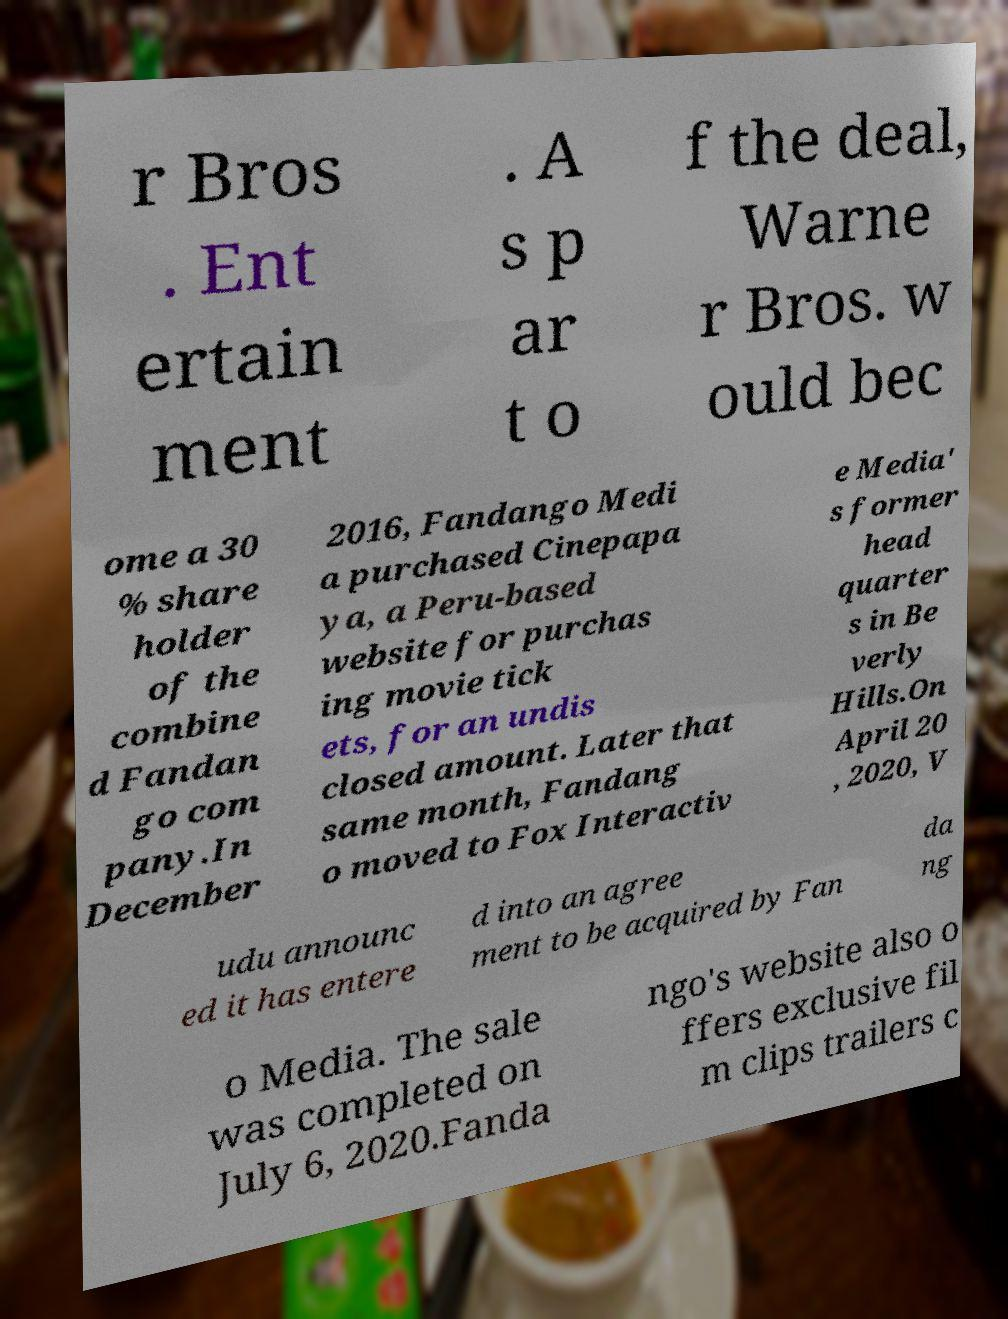For documentation purposes, I need the text within this image transcribed. Could you provide that? r Bros . Ent ertain ment . A s p ar t o f the deal, Warne r Bros. w ould bec ome a 30 % share holder of the combine d Fandan go com pany.In December 2016, Fandango Medi a purchased Cinepapa ya, a Peru-based website for purchas ing movie tick ets, for an undis closed amount. Later that same month, Fandang o moved to Fox Interactiv e Media' s former head quarter s in Be verly Hills.On April 20 , 2020, V udu announc ed it has entere d into an agree ment to be acquired by Fan da ng o Media. The sale was completed on July 6, 2020.Fanda ngo's website also o ffers exclusive fil m clips trailers c 